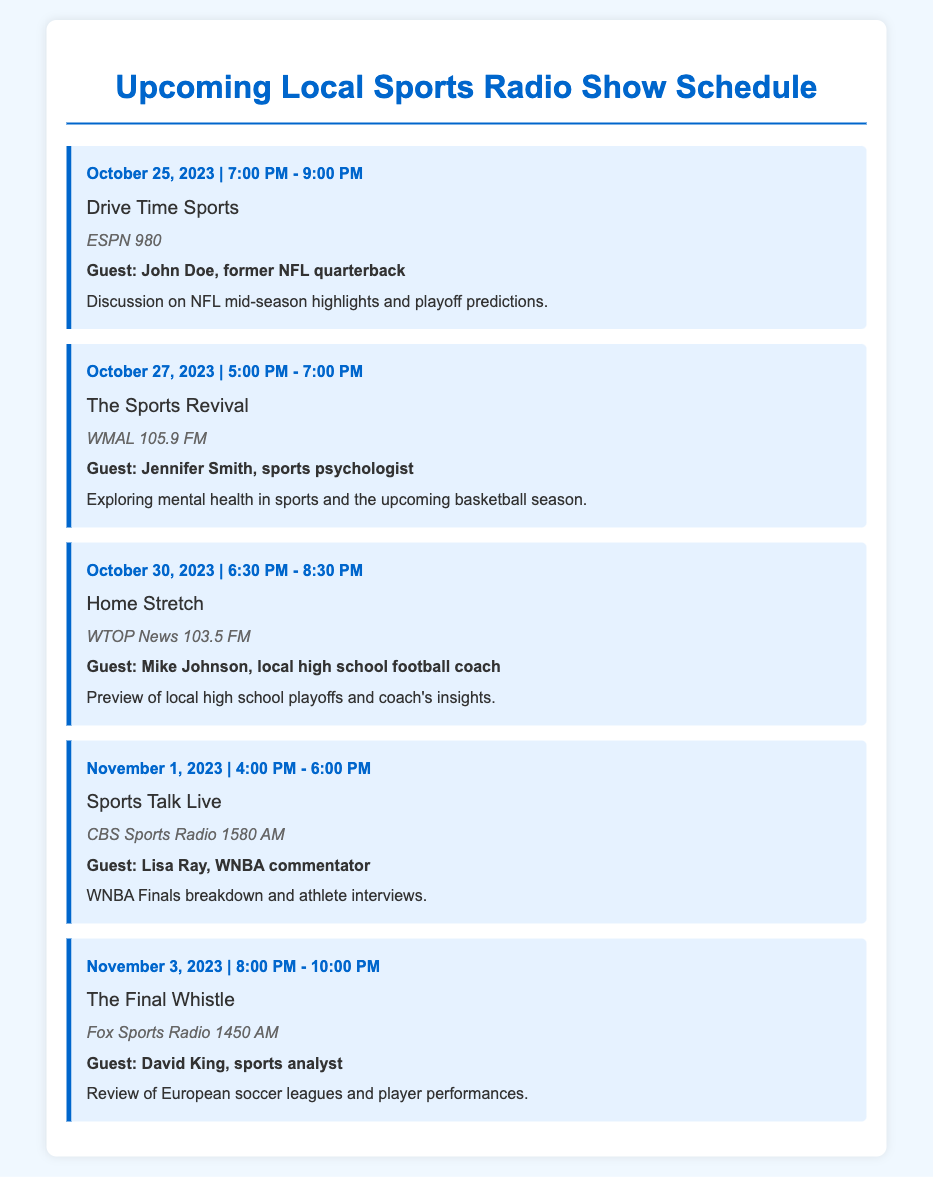What is the date of the show "Drive Time Sports"? The date mentioned for "Drive Time Sports" in the document is October 25, 2023.
Answer: October 25, 2023 Who is the guest on "The Sports Revival"? The guest for "The Sports Revival" on October 27, 2023, is Jennifer Smith, a sports psychologist.
Answer: Jennifer Smith What time does "Home Stretch" air? "Home Stretch" airs from 6:30 PM to 8:30 PM on October 30, 2023.
Answer: 6:30 PM - 8:30 PM Which radio station broadcasts "Sports Talk Live"? The radio station broadcasting "Sports Talk Live" is CBS Sports Radio 1580 AM.
Answer: CBS Sports Radio 1580 AM What is the main topic of discussion on "The Final Whistle"? "The Final Whistle" will review European soccer leagues and player performances.
Answer: European soccer leagues and player performances What type of expert is the guest on "The Sports Revival"? The guest on "The Sports Revival" is a sports psychologist, indicating a focus on mental health in sports.
Answer: Sports psychologist How many shows are scheduled before November 1, 2023? There are three shows scheduled before November 1, 2023: "Drive Time Sports," "The Sports Revival," and "Home Stretch."
Answer: Three What kind of insights will be shared by the guest on "Home Stretch"? The guest, Mike Johnson, a local high school football coach, will provide insights into local high school playoffs.
Answer: Local high school playoffs What date is the WNBA Finals breakdown scheduled for? The WNBA Finals breakdown on "Sports Talk Live" is scheduled for November 1, 2023.
Answer: November 1, 2023 